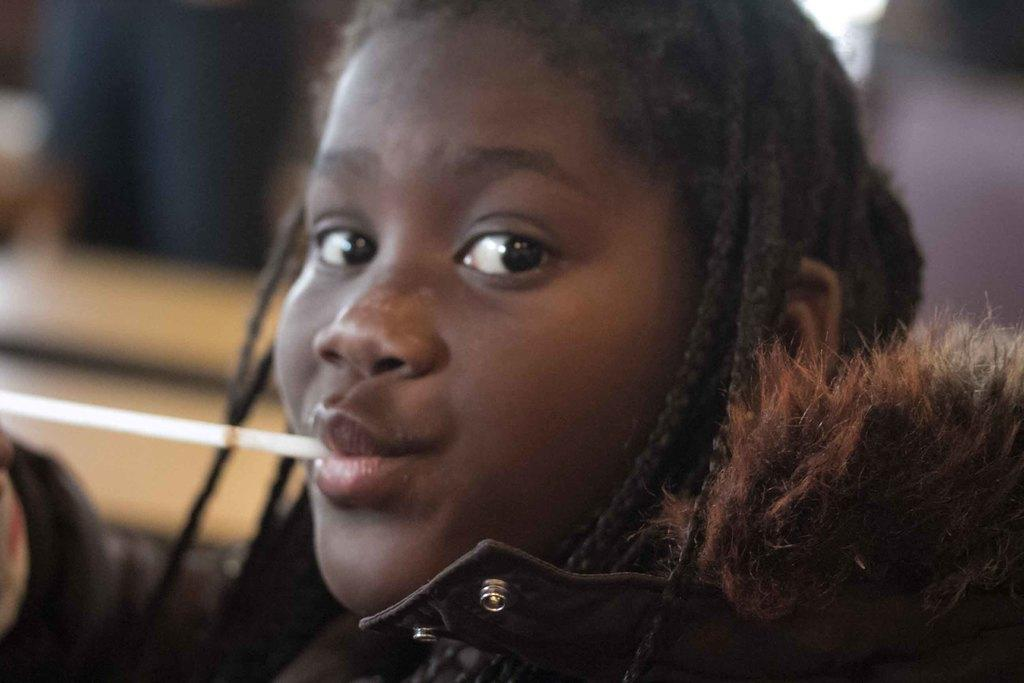Who is the main subject in the image? There is a girl in the image. What is the girl doing in the image? It appears that there is a straw in the girl's mouth. What type of linen is draped over the girl's tongue in the image? There is no linen or reference to the girl's tongue in the image. 